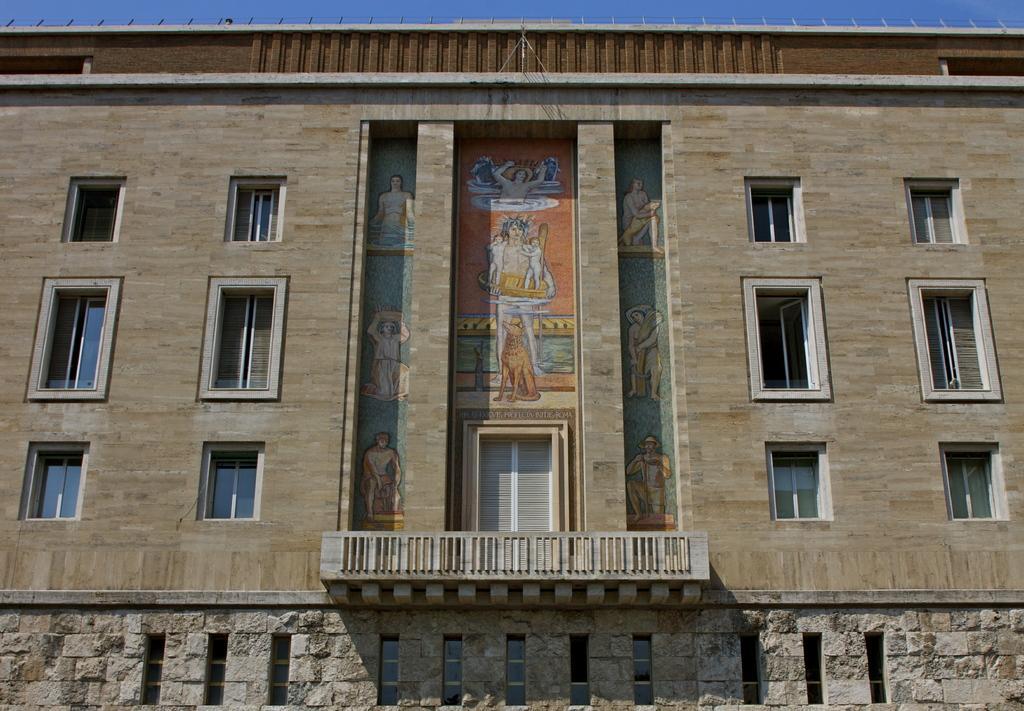In one or two sentences, can you explain what this image depicts? In this image I can see a building,glass windows,railing,door and few pictures on the wall. The sky is in blue color. 